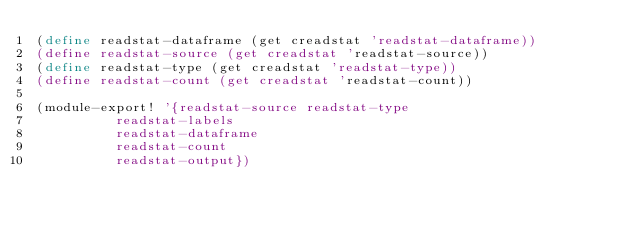<code> <loc_0><loc_0><loc_500><loc_500><_Scheme_>(define readstat-dataframe (get creadstat 'readstat-dataframe))
(define readstat-source (get creadstat 'readstat-source))
(define readstat-type (get creadstat 'readstat-type))
(define readstat-count (get creadstat 'readstat-count))

(module-export! '{readstat-source readstat-type
		  readstat-labels
		  readstat-dataframe
		  readstat-count 
		  readstat-output})
</code> 